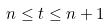Convert formula to latex. <formula><loc_0><loc_0><loc_500><loc_500>n \leq t \leq n + 1</formula> 